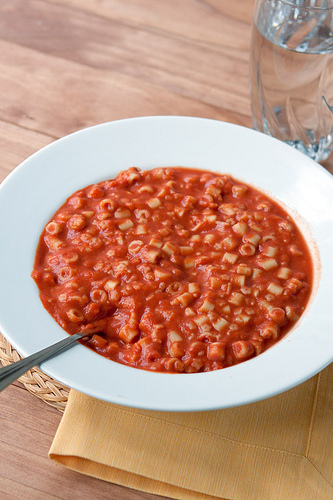<image>
Is the utensil in the food? Yes. The utensil is contained within or inside the food, showing a containment relationship. Is there a spoon in front of the plate? No. The spoon is not in front of the plate. The spatial positioning shows a different relationship between these objects. 